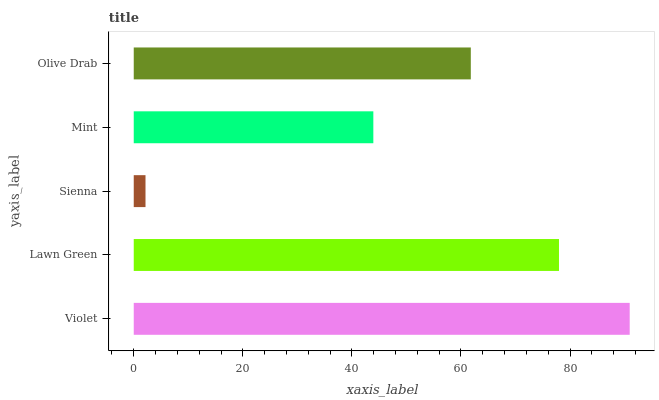Is Sienna the minimum?
Answer yes or no. Yes. Is Violet the maximum?
Answer yes or no. Yes. Is Lawn Green the minimum?
Answer yes or no. No. Is Lawn Green the maximum?
Answer yes or no. No. Is Violet greater than Lawn Green?
Answer yes or no. Yes. Is Lawn Green less than Violet?
Answer yes or no. Yes. Is Lawn Green greater than Violet?
Answer yes or no. No. Is Violet less than Lawn Green?
Answer yes or no. No. Is Olive Drab the high median?
Answer yes or no. Yes. Is Olive Drab the low median?
Answer yes or no. Yes. Is Mint the high median?
Answer yes or no. No. Is Sienna the low median?
Answer yes or no. No. 